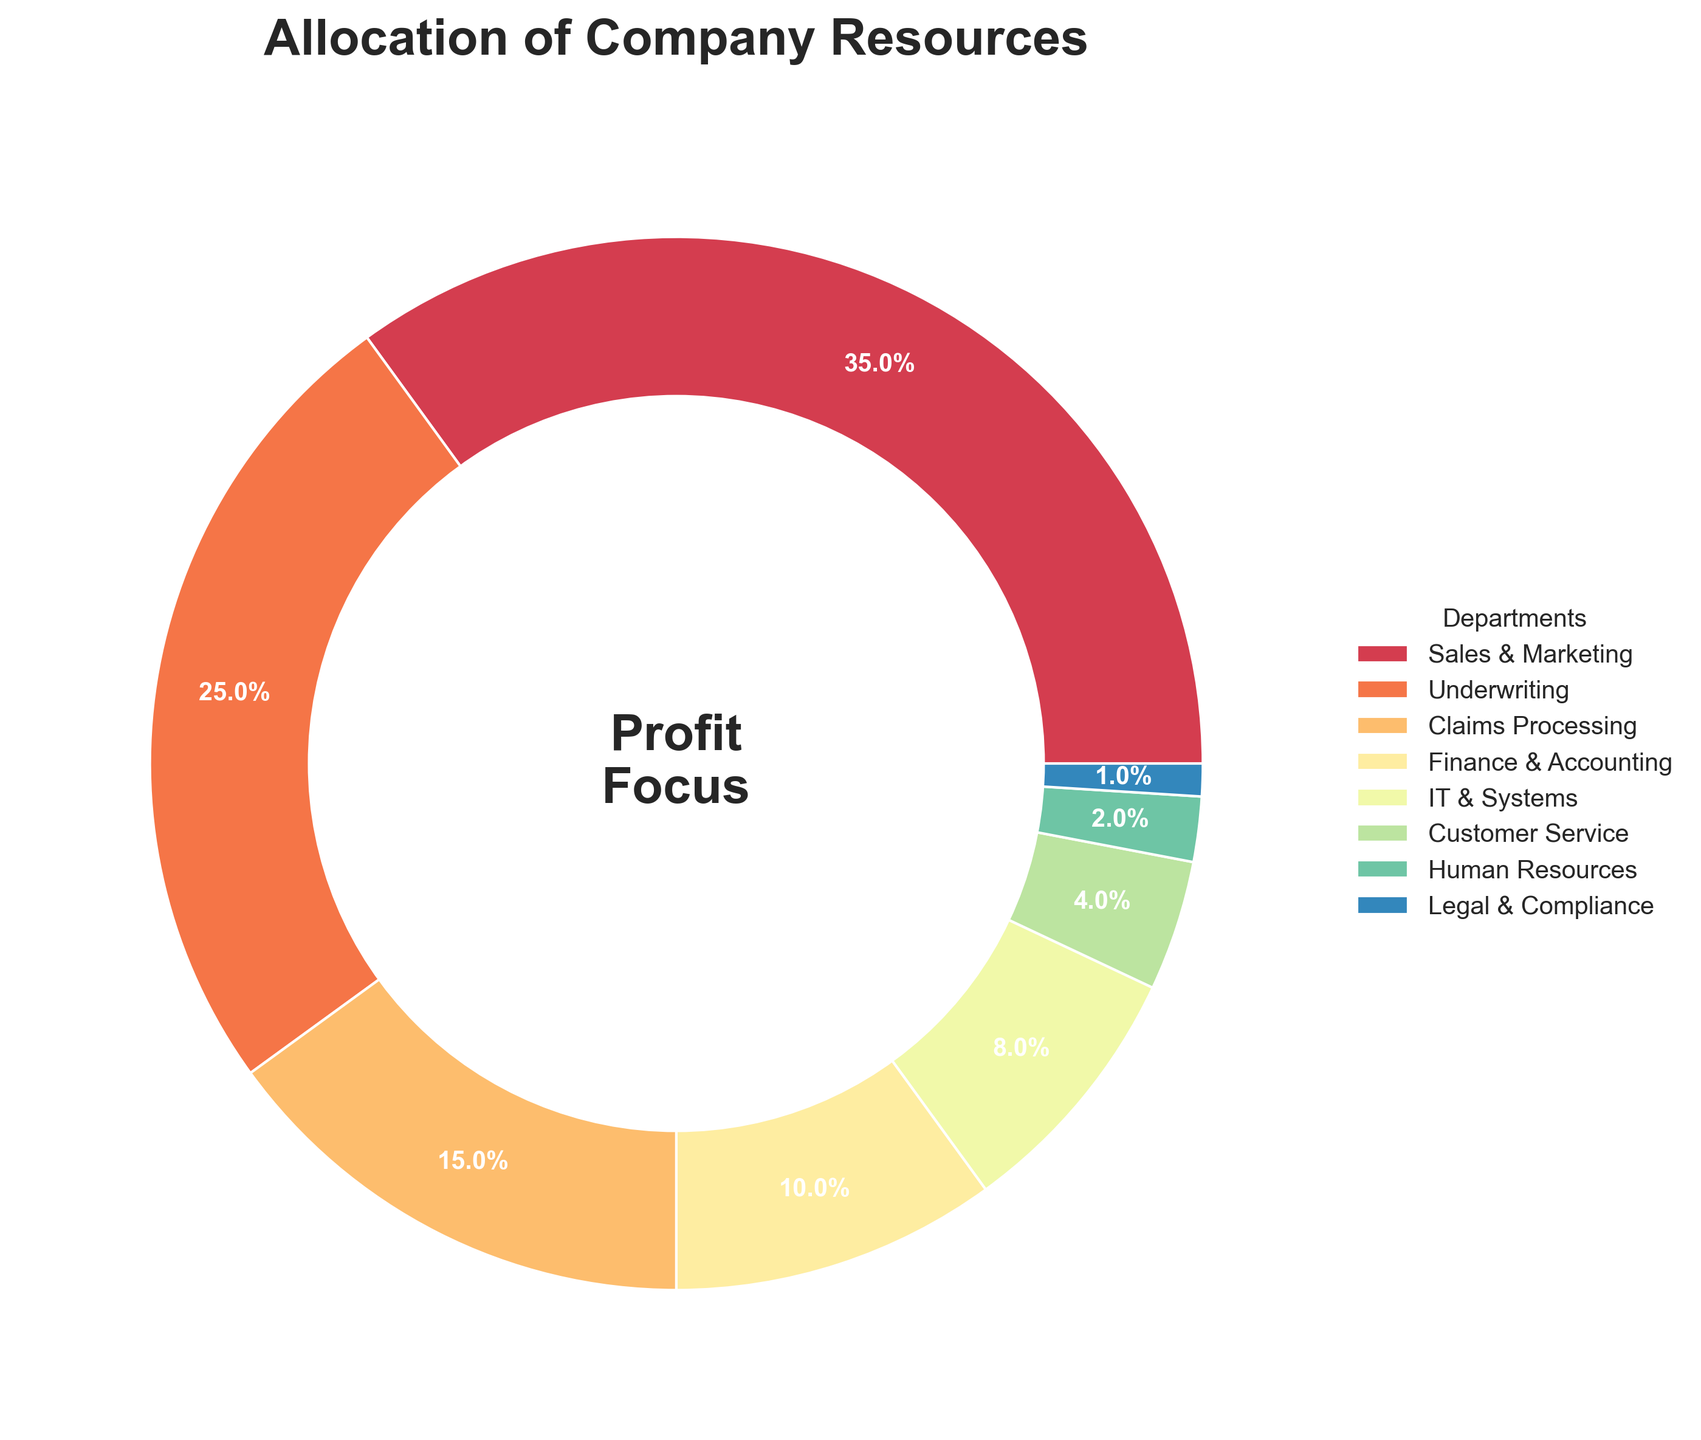what percentage of resources is allocated to operations that involve customer interaction (Sales & Marketing and Customer Service)? We need to sum the percentages of Sales & Marketing and Customer Service. Sales & Marketing has 35%, and Customer Service has 4%. The sum of these is 35% + 4% = 39%.
Answer: 39% Which department has the second-highest percentage of resources allocated to it? The figure shows that the highest allocation is to Sales & Marketing (35%). The second-highest allocation is to Underwriting, which has 25%.
Answer: Underwriting How much more is allocated to Sales & Marketing compared to Finance & Accounting? Sales & Marketing is allocated 35%, and Finance & Accounting is allocated 10%. The difference is 35% - 10% = 25%.
Answer: 25% Which department has the lowest allocation of resources? From the figure, Legal & Compliance has the lowest allocation, with 1%.
Answer: Legal & Compliance Sum the percentages of departments Finance & Accounting, IT & Systems, Customer Service, Human Resources, and Legal & Compliance. We add the percentages for these departments: 10% (Finance & Accounting) + 8% (IT & Systems) + 4% (Customer Service) + 2% (Human Resources) + 1% (Legal & Compliance). The sum is 10% + 8% + 4% + 2% + 1% = 25%.
Answer: 25% Which two departments combined have an equal allocation to Claims Processing? Claims Processing has 15%. Combining IT & Systems (8%) and Customer Service (4%) gives a sum of 8% + 4% = 12%. IT & Systems (8%) and Human Resources (2%) give a sum of 8% + 2% = 10%, and Customer Service (4%) and Human Resources (2%) give a sum of 4% + 2% = 6%. Instead, combining IT & Systems (8%) and Finance & Accounting (10%) results in 8% + 10% = 18%. Thus, none of the departmental pairs exactly equal 15%. Instead, combining IT & Systems (8%) and Customer Service (4%) and Human Resources (2%) results in 8% + 4% + 1% = 13%. Thus, no exact pair matches Claims Processing individually, but it remains the second significant allocation after two major combined departments.
Answer: None What percentage of resources is allocated to back-office operations (Finance & Accounting, IT & Systems, Human Resources, Legal & Compliance)? Sum of allocations: Finance & Accounting (10%), IT & Systems (8%), Human Resources (2%), Legal & Compliance (1%). Combined, 10% + 8% + 2% + 1% = 21%.
Answer: 21% What is the combined percentage of allocations to Underwriting and Claims Processing? Underwriting is allocated 25%, and Claims Processing is allocated 15%. The combined allocation is 25% + 15% = 40%.
Answer: 40% Which slice in the chart is the largest, and what is its percentage? The largest slice on the pie chart is for Sales & Marketing, which is labeled 35%.
Answer: Sales & Marketing, 35% How many departments have an allocation of less than 10%? Departments with less than 10% allocation are IT & Systems (8%), Customer Service (4%), Human Resources (2%), and Legal & Compliance (1%). This means there are four departments.
Answer: Four 